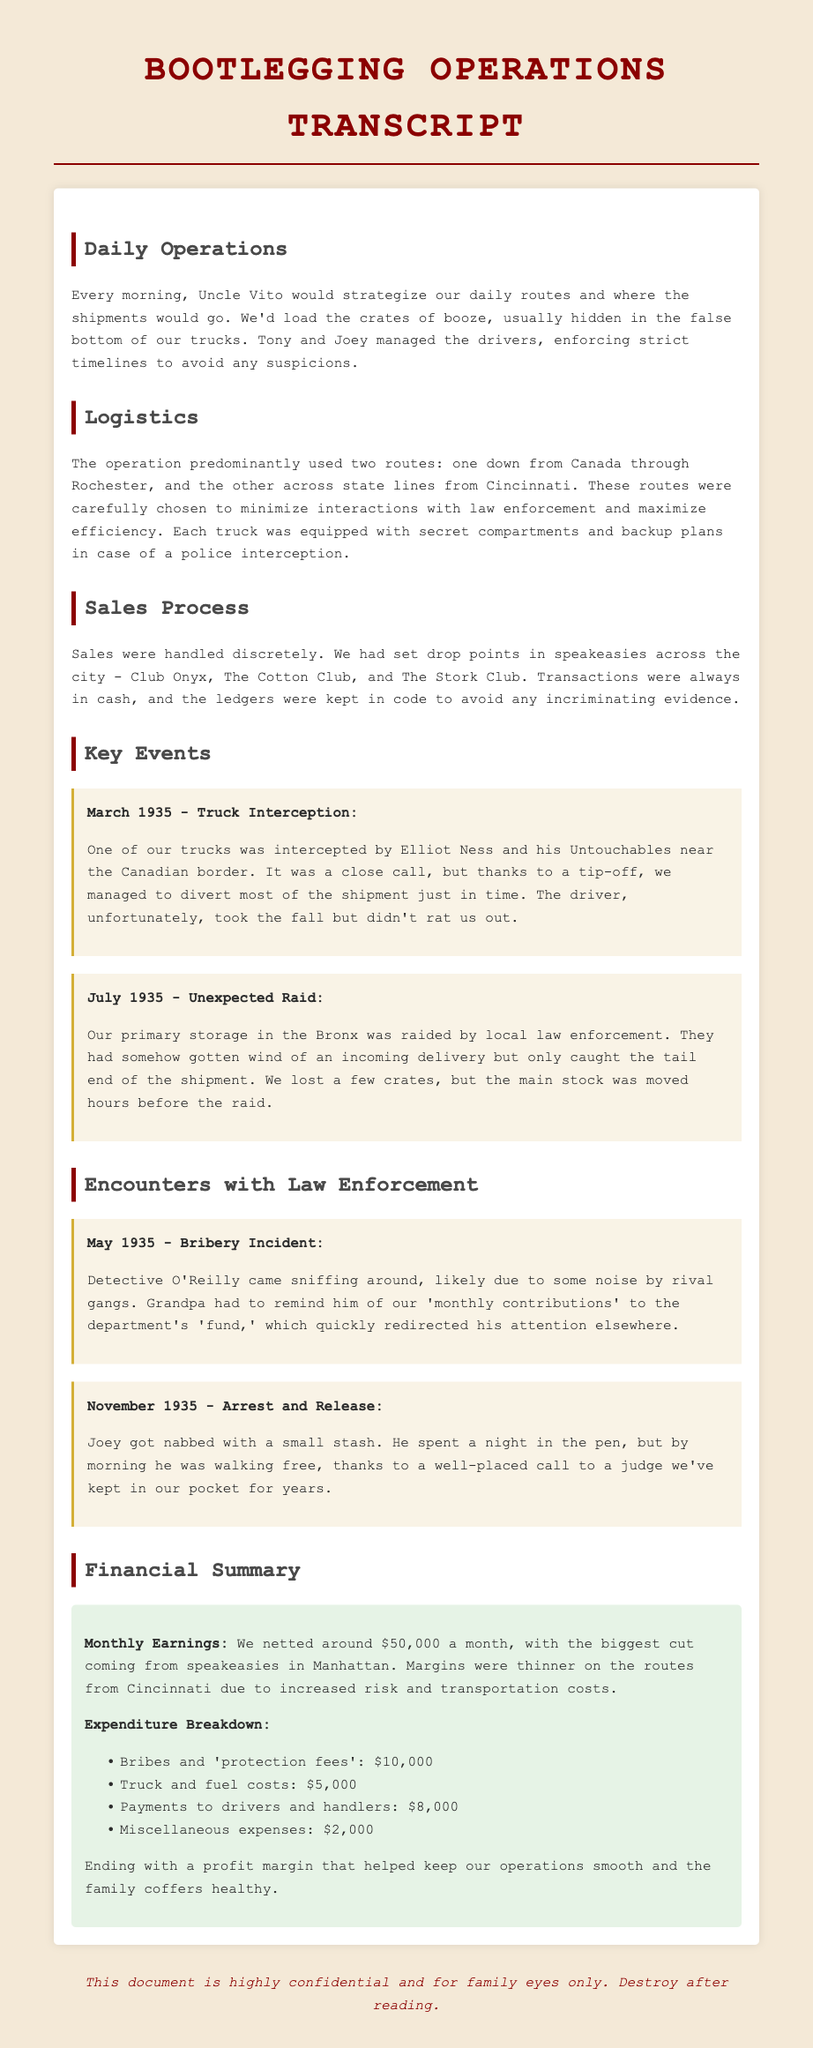What were the two main routes used for bootlegging? The document mentions two specific routes for the bootlegging operation: one down from Canada through Rochester and the other across state lines from Cincinnati.
Answer: Canada through Rochester and Cincinnati Who managed the drivers of the operation? The transcript specifies that Tony and Joey managed the drivers, ensuring they followed strict timelines.
Answer: Tony and Joey What was the monthly earnings of the operation? According to the financial summary, the operation netted around $50,000 a month from their activities.
Answer: $50,000 What was the consequence of the truck interception in March 1935? The document states that one truck was intercepted, the driver took the fall but did not rat out the family, implying an attempt to protect the operation.
Answer: The driver took the fall What happened during the unexpected raid in July 1935? The text describes that local law enforcement raided their primary storage, managing to catch only part of the shipment as the main stock was moved beforehand.
Answer: They caught the tail end of the shipment What was Detective O'Reilly investigating in May 1935? The document indicates that he was sniffing around likely due to some noise by rival gangs, leading to an interaction with the family regarding bribes.
Answer: Noise by rival gangs How many crates were lost during the July 1935 raid? The specific number of crates is not mentioned in the document; it only mentions they lost a few.
Answer: A few crates What was the amount spent on bribes and protection fees? The expenditure breakdown states that they spent $10,000 on bribes and protection fees as a part of their overall expenses.
Answer: $10,000 What did the family use to hide the booze in the trucks? The transcript reveals that they used false bottoms in the trucks to conceal the crates of booze from law enforcement.
Answer: False bottoms 